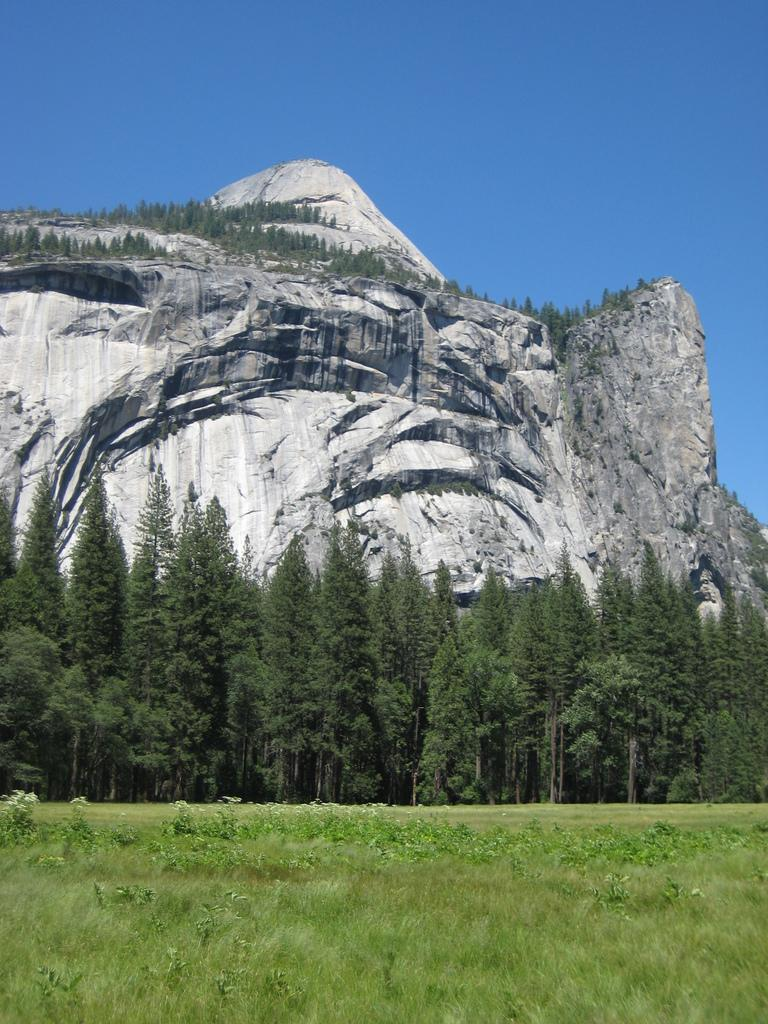What type of vegetation can be seen in the image? There are trees, plants, and grass in the image. What geological features are present in the image? There are big rock stones and a mountain in the image. What part of the natural environment is visible in the image? The sky is visible in the image. What type of jam is being served on the beds in the image? There is no jam or beds present in the image. How does the society depicted in the image interact with the mountain? There is no society depicted in the image, only natural elements such as trees, plants, grass, rock stones, and a mountain. 